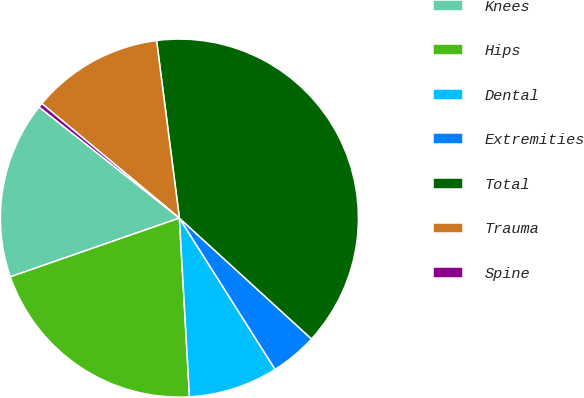Convert chart. <chart><loc_0><loc_0><loc_500><loc_500><pie_chart><fcel>Knees<fcel>Hips<fcel>Dental<fcel>Extremities<fcel>Total<fcel>Trauma<fcel>Spine<nl><fcel>15.98%<fcel>20.58%<fcel>8.08%<fcel>4.23%<fcel>38.83%<fcel>11.92%<fcel>0.39%<nl></chart> 